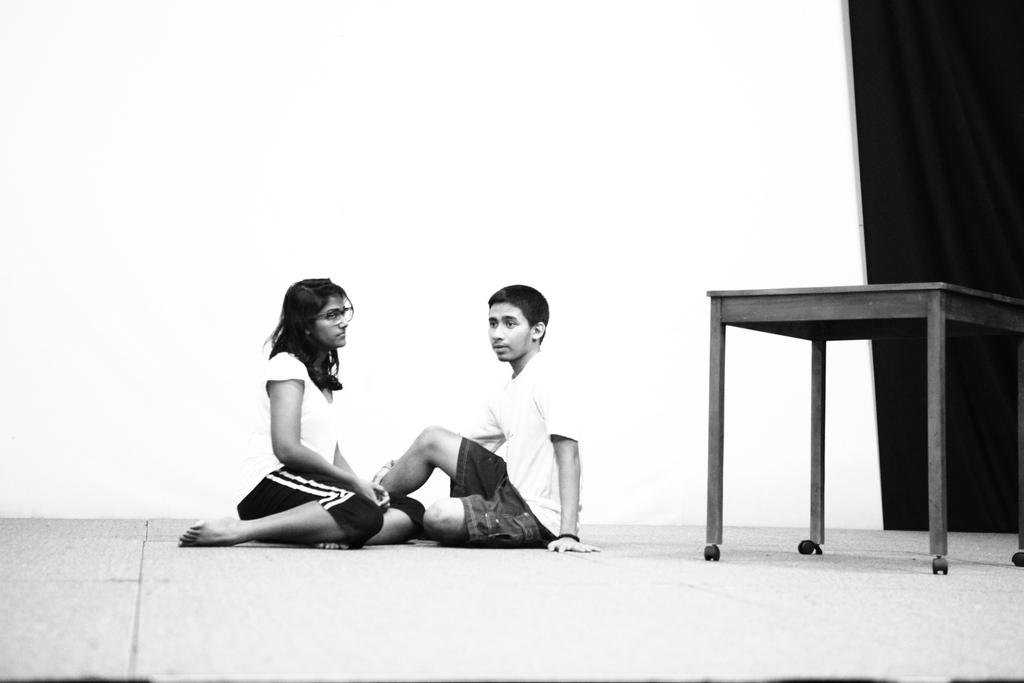What is the color of the wall in the image? The wall in the image is white. What piece of furniture is present in the image? There is a table in the image. What are the two people in the image doing? The two people are sitting on the floor in the image. How many tickets does the wealthiest person in the image have? There is no mention of tickets or wealth in the image, so it is impossible to answer this question. 